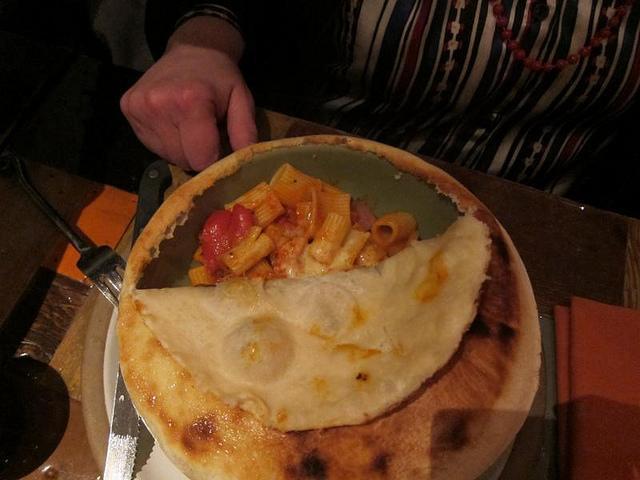Is this affirmation: "The pizza is below the person." correct?
Answer yes or no. Yes. Does the description: "The pizza is close to the person." accurately reflect the image?
Answer yes or no. Yes. 